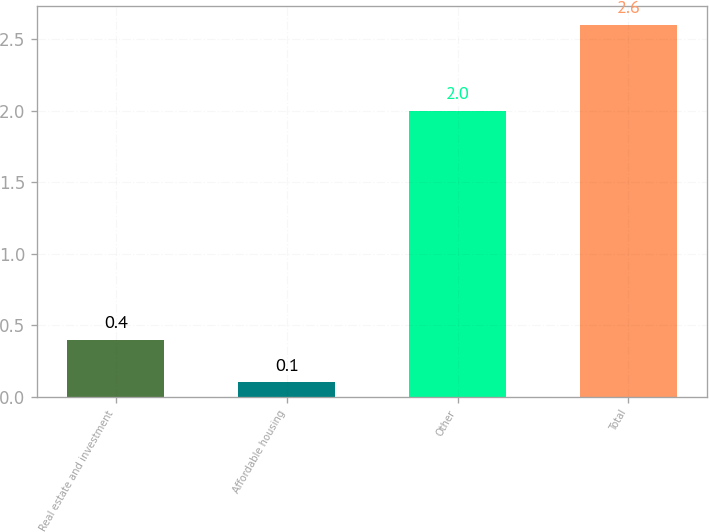Convert chart. <chart><loc_0><loc_0><loc_500><loc_500><bar_chart><fcel>Real estate and investment<fcel>Affordable housing<fcel>Other<fcel>Total<nl><fcel>0.4<fcel>0.1<fcel>2<fcel>2.6<nl></chart> 